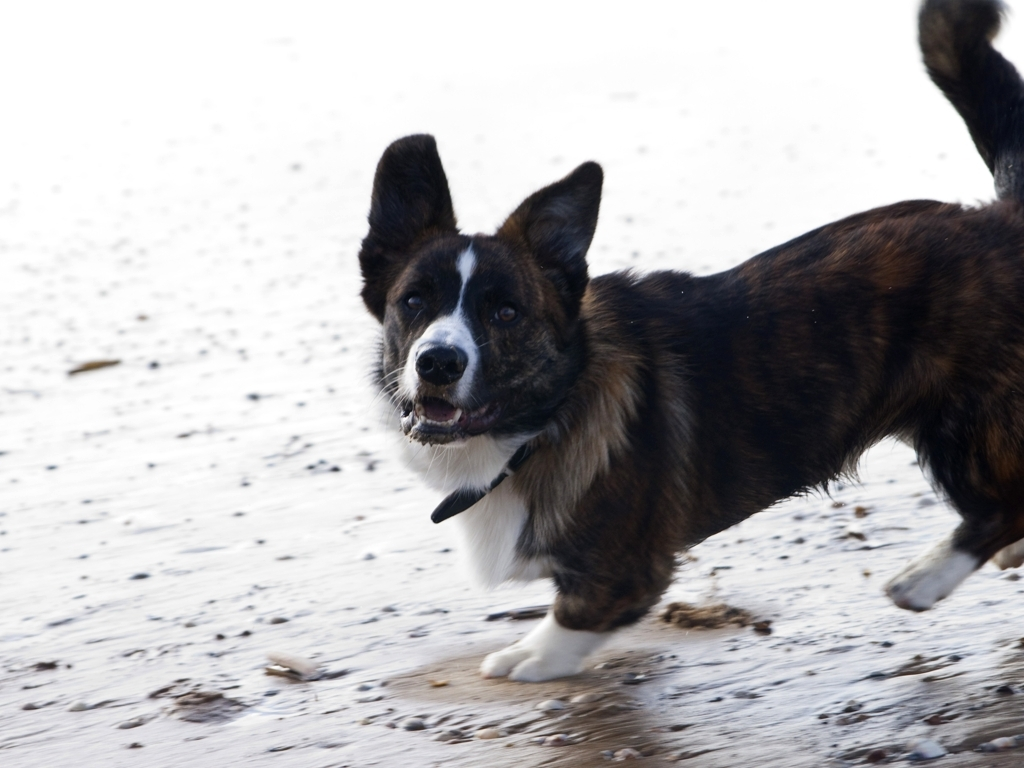Does the brown corgi retain most of its texture details?
A. No
B. Yes
Answer with the option's letter from the given choices directly.
 B. 